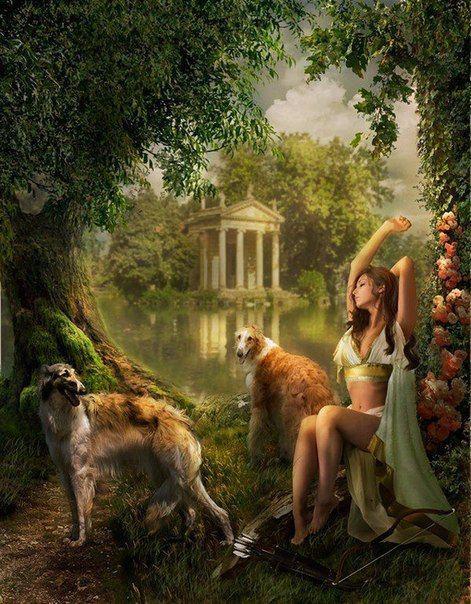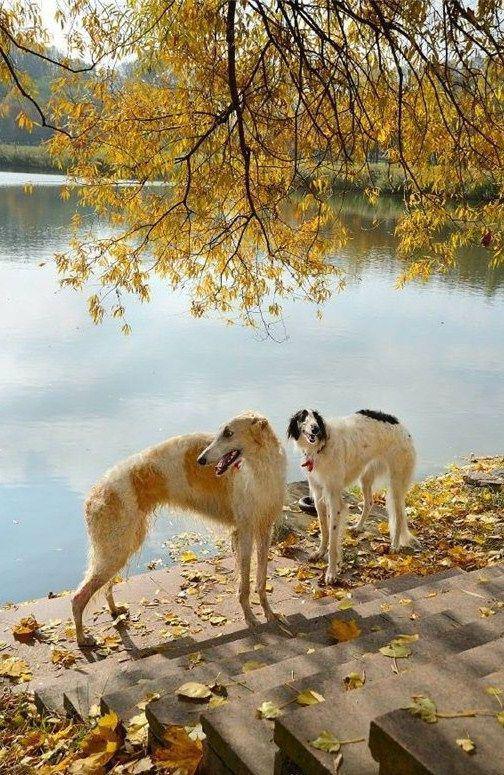The first image is the image on the left, the second image is the image on the right. Analyze the images presented: Is the assertion "A woman is sitting with her two dogs." valid? Answer yes or no. Yes. The first image is the image on the left, the second image is the image on the right. For the images displayed, is the sentence "A woman is sitting with her two dogs nearby." factually correct? Answer yes or no. Yes. 